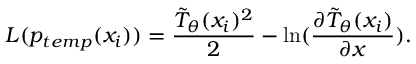Convert formula to latex. <formula><loc_0><loc_0><loc_500><loc_500>L ( p _ { t e m p } ( x _ { i } ) ) = \frac { \tilde { T } _ { \theta } ( x _ { i } ) ^ { 2 } } { 2 } - \ln ( \frac { \partial \tilde { T } _ { \theta } ( x _ { i } ) } { \partial x } ) .</formula> 